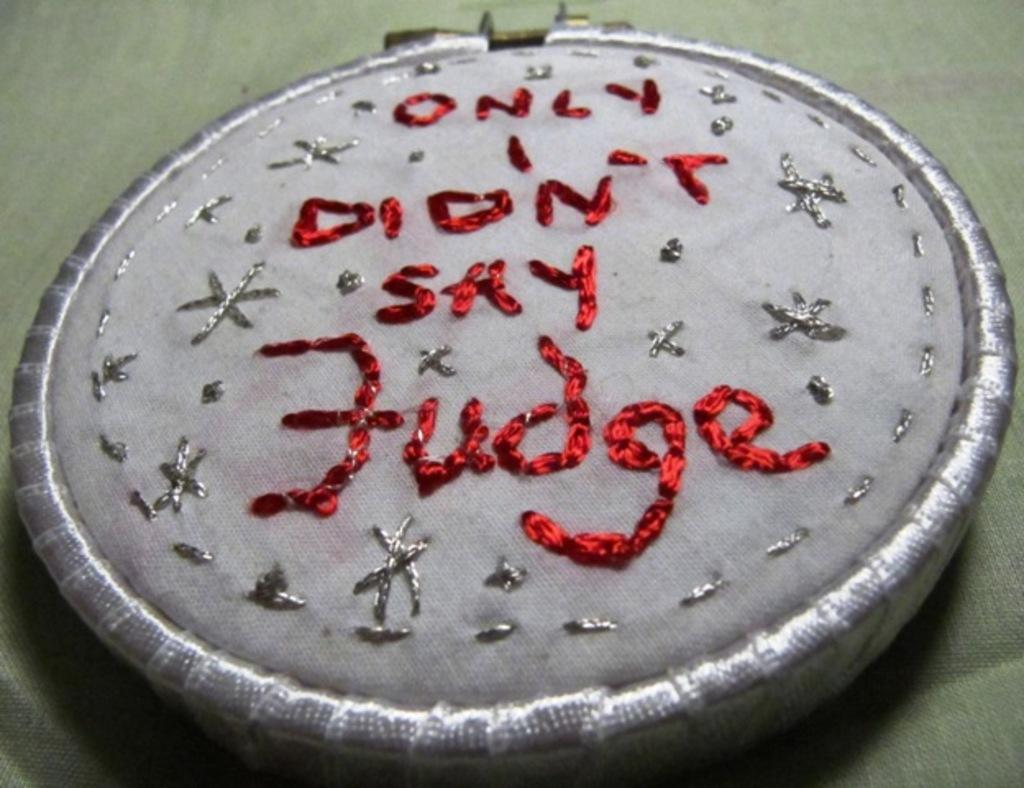What is the main feature of the image? There is a quotation in the image. How is the quotation created? The quotation is made with threads. What color are the threads used to create the quotation? The threads are red in color. How does the tendency of the cork affect the volleyball game in the image? There is no volleyball game or cork present in the image; it features a quotation made with red threads. 